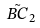Convert formula to latex. <formula><loc_0><loc_0><loc_500><loc_500>\tilde { B C } _ { 2 }</formula> 